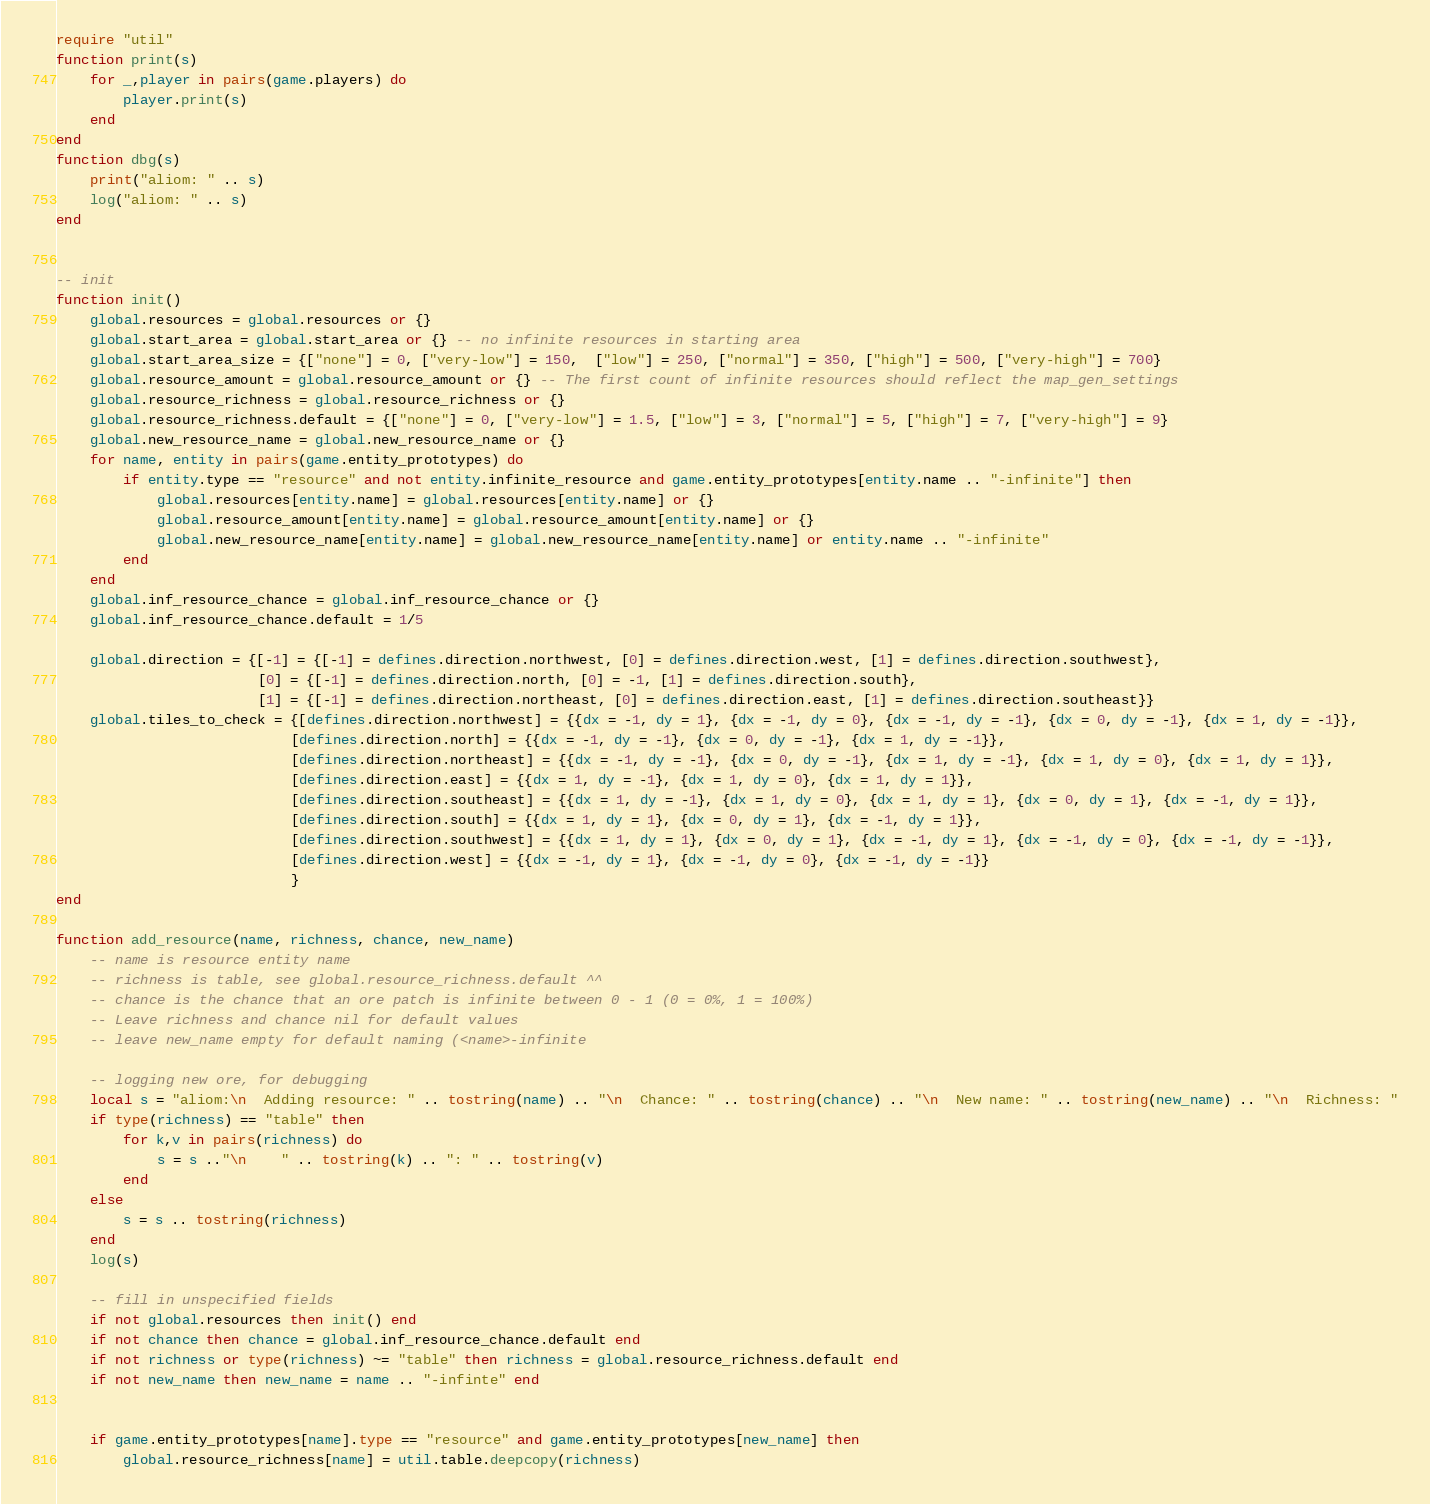Convert code to text. <code><loc_0><loc_0><loc_500><loc_500><_Lua_>require "util"
function print(s)
	for _,player in pairs(game.players) do
		player.print(s)
	end
end
function dbg(s)
	print("aliom: " .. s)
	log("aliom: " .. s)
end


-- init
function init()
	global.resources = global.resources or {}
	global.start_area = global.start_area or {} -- no infinite resources in starting area
	global.start_area_size = {["none"] = 0, ["very-low"] = 150,  ["low"] = 250, ["normal"] = 350, ["high"] = 500, ["very-high"] = 700}
	global.resource_amount = global.resource_amount or {} -- The first count of infinite resources should reflect the map_gen_settings
	global.resource_richness = global.resource_richness or {}
	global.resource_richness.default = {["none"] = 0, ["very-low"] = 1.5, ["low"] = 3, ["normal"] = 5, ["high"] = 7, ["very-high"] = 9}
	global.new_resource_name = global.new_resource_name or {}
	for name, entity in pairs(game.entity_prototypes) do
		if entity.type == "resource" and not entity.infinite_resource and game.entity_prototypes[entity.name .. "-infinite"] then
			global.resources[entity.name] = global.resources[entity.name] or {}
			global.resource_amount[entity.name] = global.resource_amount[entity.name] or {}
			global.new_resource_name[entity.name] = global.new_resource_name[entity.name] or entity.name .. "-infinite"
		end
	end
	global.inf_resource_chance = global.inf_resource_chance or {}
	global.inf_resource_chance.default = 1/5
	
	global.direction = {[-1] = {[-1] = defines.direction.northwest, [0] = defines.direction.west, [1] = defines.direction.southwest}, 
						[0] = {[-1] = defines.direction.north, [0] = -1, [1] = defines.direction.south}, 
						[1] = {[-1] = defines.direction.northeast, [0] = defines.direction.east, [1] = defines.direction.southeast}}
	global.tiles_to_check = {[defines.direction.northwest] = {{dx = -1, dy = 1}, {dx = -1, dy = 0}, {dx = -1, dy = -1}, {dx = 0, dy = -1}, {dx = 1, dy = -1}}, 
							[defines.direction.north] = {{dx = -1, dy = -1}, {dx = 0, dy = -1}, {dx = 1, dy = -1}}, 
							[defines.direction.northeast] = {{dx = -1, dy = -1}, {dx = 0, dy = -1}, {dx = 1, dy = -1}, {dx = 1, dy = 0}, {dx = 1, dy = 1}}, 
							[defines.direction.east] = {{dx = 1, dy = -1}, {dx = 1, dy = 0}, {dx = 1, dy = 1}}, 
							[defines.direction.southeast] = {{dx = 1, dy = -1}, {dx = 1, dy = 0}, {dx = 1, dy = 1}, {dx = 0, dy = 1}, {dx = -1, dy = 1}}, 
							[defines.direction.south] = {{dx = 1, dy = 1}, {dx = 0, dy = 1}, {dx = -1, dy = 1}}, 
							[defines.direction.southwest] = {{dx = 1, dy = 1}, {dx = 0, dy = 1}, {dx = -1, dy = 1}, {dx = -1, dy = 0}, {dx = -1, dy = -1}}, 
							[defines.direction.west] = {{dx = -1, dy = 1}, {dx = -1, dy = 0}, {dx = -1, dy = -1}}
							}
end

function add_resource(name, richness, chance, new_name)
	-- name is resource entity name
	-- richness is table, see global.resource_richness.default ^^
	-- chance is the chance that an ore patch is infinite between 0 - 1 (0 = 0%, 1 = 100%)
	-- Leave richness and chance nil for default values
    -- leave new_name empty for default naming (<name>-infinite
	
	-- logging new ore, for debugging
	local s = "aliom:\n  Adding resource: " .. tostring(name) .. "\n  Chance: " .. tostring(chance) .. "\n  New name: " .. tostring(new_name) .. "\n  Richness: "
	if type(richness) == "table" then
		for k,v in pairs(richness) do
			s = s .."\n    " .. tostring(k) .. ": " .. tostring(v)
		end
	else
		s = s .. tostring(richness)
	end
	log(s)
	
	-- fill in unspecified fields
	if not global.resources then init() end
	if not chance then chance = global.inf_resource_chance.default end
	if not richness or type(richness) ~= "table" then richness = global.resource_richness.default end
	if not new_name then new_name = name .. "-infinte" end
	
	
	if game.entity_prototypes[name].type == "resource" and game.entity_prototypes[new_name] then
		global.resource_richness[name] = util.table.deepcopy(richness)</code> 